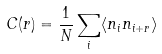<formula> <loc_0><loc_0><loc_500><loc_500>C ( r ) = \frac { 1 } { N } \sum _ { i } \langle n _ { i } n _ { i + r } \rangle</formula> 